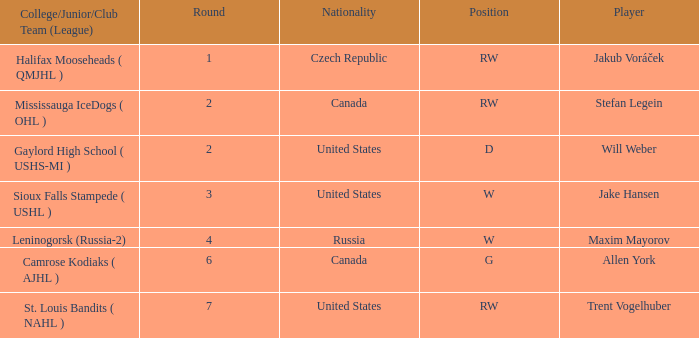What college or league did the round 2 pick with d position come from? Gaylord High School ( USHS-MI ). 